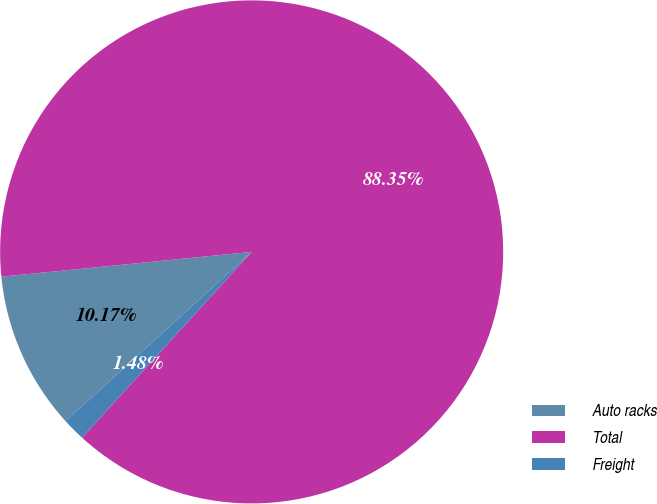Convert chart. <chart><loc_0><loc_0><loc_500><loc_500><pie_chart><fcel>Auto racks<fcel>Total<fcel>Freight<nl><fcel>10.17%<fcel>88.35%<fcel>1.48%<nl></chart> 